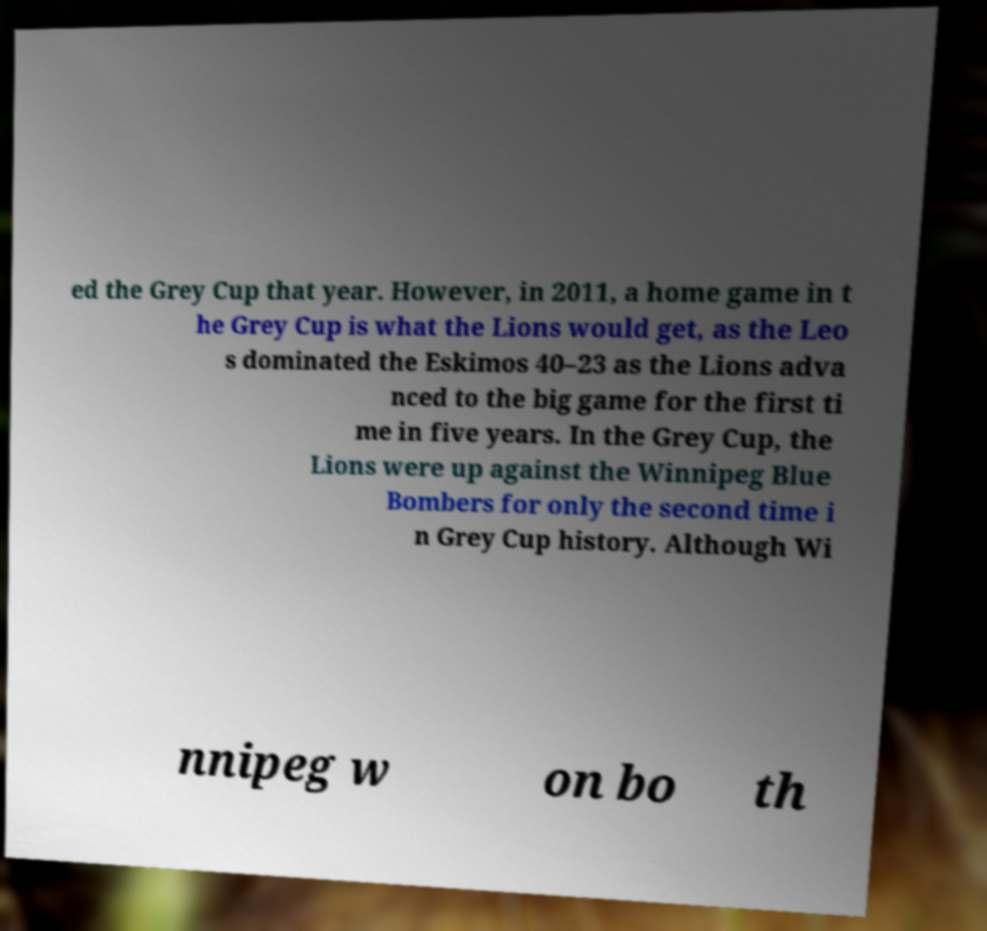I need the written content from this picture converted into text. Can you do that? ed the Grey Cup that year. However, in 2011, a home game in t he Grey Cup is what the Lions would get, as the Leo s dominated the Eskimos 40–23 as the Lions adva nced to the big game for the first ti me in five years. In the Grey Cup, the Lions were up against the Winnipeg Blue Bombers for only the second time i n Grey Cup history. Although Wi nnipeg w on bo th 